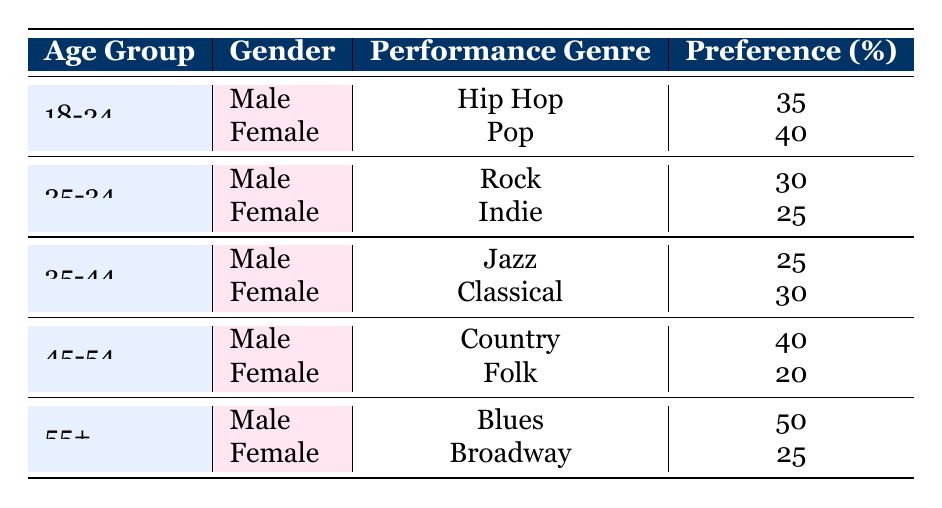What is the preferred performance genre for females aged 18-24? The table shows that for females aged 18-24, the preferred performance genre is Pop with a preference percentage of 40.
Answer: Pop What percentage of males aged 45-54 prefer Country as their performance genre? From the table, we see that males in the age group of 45-54 prefer Country, with a preference percentage of 40.
Answer: 40 Which gender and age group prefers Jazz more? The table indicates that for the 35-44 age group, males have a preference of 25 for Jazz while females have a preference of 30 for Classical. Therefore, females in the 35-44 age group prefer their genre more than males do for Jazz.
Answer: Female 35-44 How many total unique performance genres are represented in the table? The genres listed are Hip Hop, Pop, Rock, Indie, Jazz, Classical, Country, Folk, Blues, and Broadway, totaling 10 unique genres.
Answer: 10 Is there any age group where females have a higher preference percentage than males? Analyzing the data, for the 18-24 age group, females prefer Pop (40) more than males who prefer Hip Hop (35); for 35-44, females prefer Classical (30) over males who prefer Jazz (25). Therefore, yes, there are age groups where females have a higher preference.
Answer: Yes What is the difference in preference percentage between males aged 55 and females aged 55 for their top genres? The table shows that males aged 55+ prefer Blues with a percentage of 50, while females prefer Broadway with a percentage of 25. The difference is 50 - 25 = 25.
Answer: 25 What is the average preference percentage for performance genres among females across all age groups? Summing the preferences for females: 40 (18-24) + 25 (25-34) + 30 (35-44) + 20 (45-54) + 25 (55+) = 170. There are 5 data points, so averaging gives 170 / 5 = 34.
Answer: 34 Which age group has the highest preference percentage among males and what is the genre? For males, the highest preference percentage is 50 for the age group 55+, with Blues as the genre.
Answer: 55+ Blues Do both males and females aged 45-54 have a preference percentage above 30? Males aged 45-54 have a preference for Country at 40, while females have a preference for Folk at 20. Therefore, females do not exceed 30.
Answer: No 